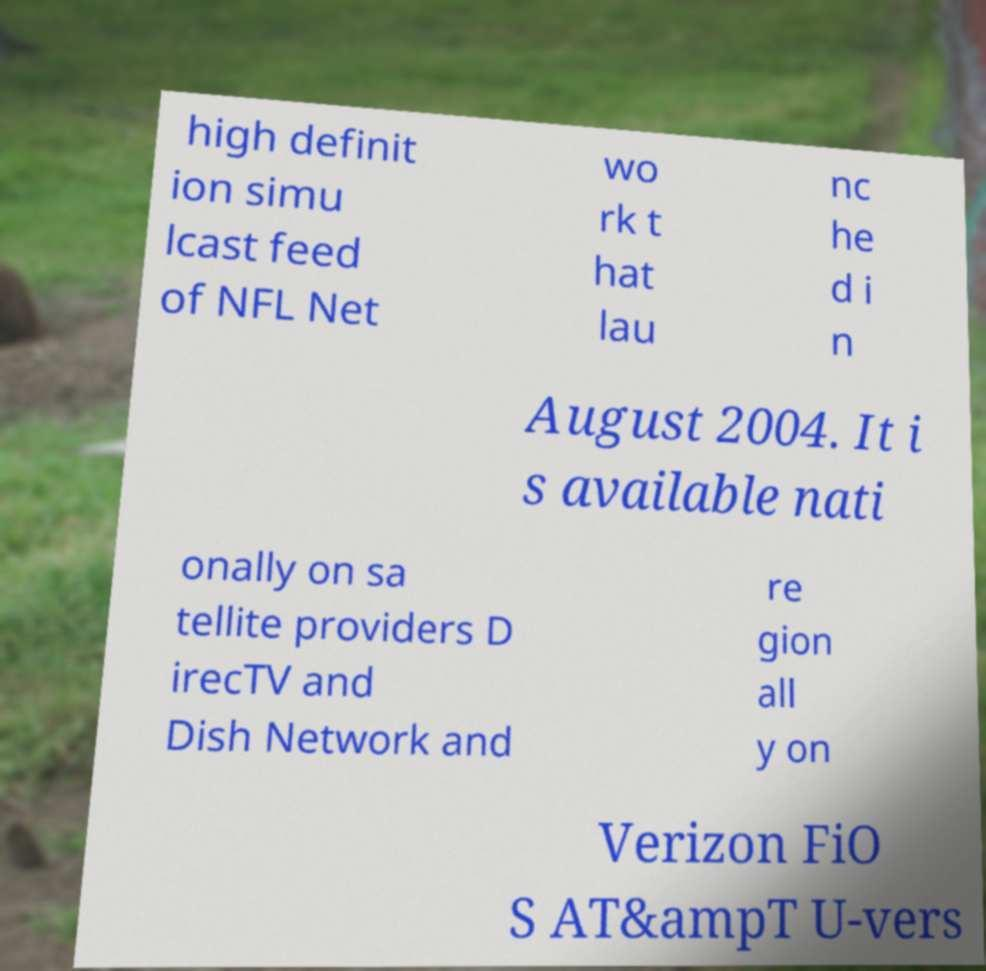There's text embedded in this image that I need extracted. Can you transcribe it verbatim? high definit ion simu lcast feed of NFL Net wo rk t hat lau nc he d i n August 2004. It i s available nati onally on sa tellite providers D irecTV and Dish Network and re gion all y on Verizon FiO S AT&ampT U-vers 